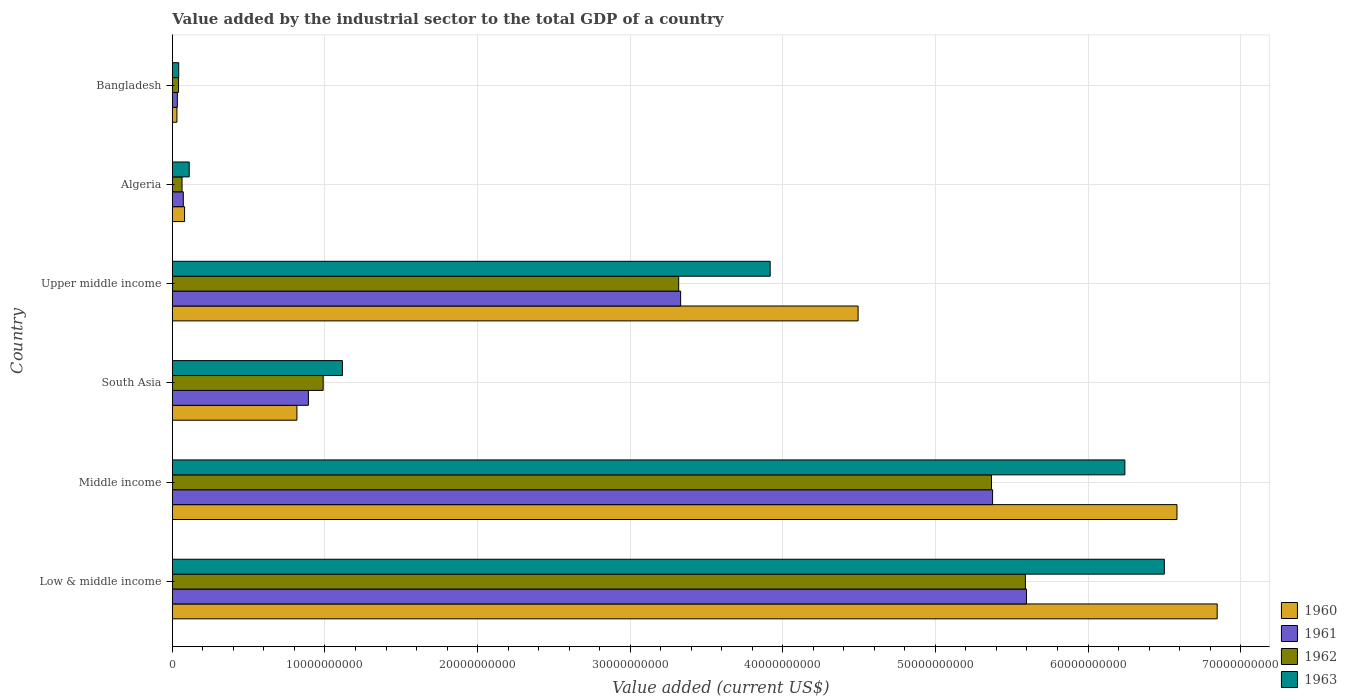How many different coloured bars are there?
Ensure brevity in your answer.  4. How many groups of bars are there?
Offer a very short reply. 6. How many bars are there on the 5th tick from the top?
Offer a very short reply. 4. How many bars are there on the 2nd tick from the bottom?
Make the answer very short. 4. In how many cases, is the number of bars for a given country not equal to the number of legend labels?
Your answer should be very brief. 0. What is the value added by the industrial sector to the total GDP in 1961 in Bangladesh?
Your answer should be very brief. 3.27e+08. Across all countries, what is the maximum value added by the industrial sector to the total GDP in 1962?
Provide a succinct answer. 5.59e+1. Across all countries, what is the minimum value added by the industrial sector to the total GDP in 1962?
Provide a succinct answer. 4.05e+08. In which country was the value added by the industrial sector to the total GDP in 1961 maximum?
Give a very brief answer. Low & middle income. In which country was the value added by the industrial sector to the total GDP in 1961 minimum?
Your answer should be compact. Bangladesh. What is the total value added by the industrial sector to the total GDP in 1961 in the graph?
Offer a terse response. 1.53e+11. What is the difference between the value added by the industrial sector to the total GDP in 1963 in Low & middle income and that in Upper middle income?
Provide a succinct answer. 2.58e+1. What is the difference between the value added by the industrial sector to the total GDP in 1962 in Middle income and the value added by the industrial sector to the total GDP in 1960 in Low & middle income?
Give a very brief answer. -1.48e+1. What is the average value added by the industrial sector to the total GDP in 1961 per country?
Offer a very short reply. 2.55e+1. What is the difference between the value added by the industrial sector to the total GDP in 1961 and value added by the industrial sector to the total GDP in 1962 in Bangladesh?
Your answer should be very brief. -7.74e+07. In how many countries, is the value added by the industrial sector to the total GDP in 1963 greater than 46000000000 US$?
Provide a succinct answer. 2. What is the ratio of the value added by the industrial sector to the total GDP in 1962 in Middle income to that in Upper middle income?
Offer a terse response. 1.62. Is the difference between the value added by the industrial sector to the total GDP in 1961 in South Asia and Upper middle income greater than the difference between the value added by the industrial sector to the total GDP in 1962 in South Asia and Upper middle income?
Provide a short and direct response. No. What is the difference between the highest and the second highest value added by the industrial sector to the total GDP in 1961?
Offer a terse response. 2.22e+09. What is the difference between the highest and the lowest value added by the industrial sector to the total GDP in 1960?
Your answer should be compact. 6.82e+1. In how many countries, is the value added by the industrial sector to the total GDP in 1960 greater than the average value added by the industrial sector to the total GDP in 1960 taken over all countries?
Offer a terse response. 3. What does the 1st bar from the top in Middle income represents?
Your answer should be very brief. 1963. Is it the case that in every country, the sum of the value added by the industrial sector to the total GDP in 1961 and value added by the industrial sector to the total GDP in 1962 is greater than the value added by the industrial sector to the total GDP in 1963?
Offer a terse response. Yes. How many countries are there in the graph?
Offer a very short reply. 6. What is the difference between two consecutive major ticks on the X-axis?
Your answer should be compact. 1.00e+1. Are the values on the major ticks of X-axis written in scientific E-notation?
Ensure brevity in your answer.  No. Does the graph contain grids?
Your answer should be compact. Yes. What is the title of the graph?
Provide a short and direct response. Value added by the industrial sector to the total GDP of a country. Does "1972" appear as one of the legend labels in the graph?
Offer a terse response. No. What is the label or title of the X-axis?
Provide a short and direct response. Value added (current US$). What is the label or title of the Y-axis?
Provide a short and direct response. Country. What is the Value added (current US$) in 1960 in Low & middle income?
Give a very brief answer. 6.85e+1. What is the Value added (current US$) in 1961 in Low & middle income?
Offer a very short reply. 5.60e+1. What is the Value added (current US$) of 1962 in Low & middle income?
Make the answer very short. 5.59e+1. What is the Value added (current US$) of 1963 in Low & middle income?
Provide a succinct answer. 6.50e+1. What is the Value added (current US$) in 1960 in Middle income?
Provide a short and direct response. 6.58e+1. What is the Value added (current US$) in 1961 in Middle income?
Keep it short and to the point. 5.37e+1. What is the Value added (current US$) in 1962 in Middle income?
Give a very brief answer. 5.37e+1. What is the Value added (current US$) in 1963 in Middle income?
Provide a succinct answer. 6.24e+1. What is the Value added (current US$) in 1960 in South Asia?
Give a very brief answer. 8.16e+09. What is the Value added (current US$) in 1961 in South Asia?
Offer a terse response. 8.91e+09. What is the Value added (current US$) in 1962 in South Asia?
Offer a very short reply. 9.88e+09. What is the Value added (current US$) of 1963 in South Asia?
Make the answer very short. 1.11e+1. What is the Value added (current US$) of 1960 in Upper middle income?
Provide a short and direct response. 4.49e+1. What is the Value added (current US$) of 1961 in Upper middle income?
Ensure brevity in your answer.  3.33e+1. What is the Value added (current US$) of 1962 in Upper middle income?
Make the answer very short. 3.32e+1. What is the Value added (current US$) in 1963 in Upper middle income?
Keep it short and to the point. 3.92e+1. What is the Value added (current US$) in 1960 in Algeria?
Offer a very short reply. 8.00e+08. What is the Value added (current US$) in 1961 in Algeria?
Your answer should be very brief. 7.17e+08. What is the Value added (current US$) of 1962 in Algeria?
Your answer should be very brief. 6.34e+08. What is the Value added (current US$) in 1963 in Algeria?
Provide a short and direct response. 1.10e+09. What is the Value added (current US$) in 1960 in Bangladesh?
Give a very brief answer. 2.98e+08. What is the Value added (current US$) of 1961 in Bangladesh?
Your answer should be very brief. 3.27e+08. What is the Value added (current US$) in 1962 in Bangladesh?
Your answer should be very brief. 4.05e+08. What is the Value added (current US$) in 1963 in Bangladesh?
Your answer should be compact. 4.15e+08. Across all countries, what is the maximum Value added (current US$) of 1960?
Give a very brief answer. 6.85e+1. Across all countries, what is the maximum Value added (current US$) of 1961?
Offer a terse response. 5.60e+1. Across all countries, what is the maximum Value added (current US$) of 1962?
Offer a very short reply. 5.59e+1. Across all countries, what is the maximum Value added (current US$) of 1963?
Make the answer very short. 6.50e+1. Across all countries, what is the minimum Value added (current US$) in 1960?
Make the answer very short. 2.98e+08. Across all countries, what is the minimum Value added (current US$) in 1961?
Keep it short and to the point. 3.27e+08. Across all countries, what is the minimum Value added (current US$) of 1962?
Offer a very short reply. 4.05e+08. Across all countries, what is the minimum Value added (current US$) of 1963?
Give a very brief answer. 4.15e+08. What is the total Value added (current US$) of 1960 in the graph?
Keep it short and to the point. 1.88e+11. What is the total Value added (current US$) in 1961 in the graph?
Offer a very short reply. 1.53e+11. What is the total Value added (current US$) in 1962 in the graph?
Your answer should be compact. 1.54e+11. What is the total Value added (current US$) in 1963 in the graph?
Your answer should be very brief. 1.79e+11. What is the difference between the Value added (current US$) in 1960 in Low & middle income and that in Middle income?
Keep it short and to the point. 2.63e+09. What is the difference between the Value added (current US$) of 1961 in Low & middle income and that in Middle income?
Offer a terse response. 2.22e+09. What is the difference between the Value added (current US$) in 1962 in Low & middle income and that in Middle income?
Offer a very short reply. 2.22e+09. What is the difference between the Value added (current US$) in 1963 in Low & middle income and that in Middle income?
Give a very brief answer. 2.59e+09. What is the difference between the Value added (current US$) of 1960 in Low & middle income and that in South Asia?
Make the answer very short. 6.03e+1. What is the difference between the Value added (current US$) of 1961 in Low & middle income and that in South Asia?
Provide a short and direct response. 4.71e+1. What is the difference between the Value added (current US$) of 1962 in Low & middle income and that in South Asia?
Your response must be concise. 4.60e+1. What is the difference between the Value added (current US$) in 1963 in Low & middle income and that in South Asia?
Offer a very short reply. 5.39e+1. What is the difference between the Value added (current US$) in 1960 in Low & middle income and that in Upper middle income?
Ensure brevity in your answer.  2.35e+1. What is the difference between the Value added (current US$) of 1961 in Low & middle income and that in Upper middle income?
Provide a short and direct response. 2.27e+1. What is the difference between the Value added (current US$) in 1962 in Low & middle income and that in Upper middle income?
Your answer should be very brief. 2.27e+1. What is the difference between the Value added (current US$) of 1963 in Low & middle income and that in Upper middle income?
Your response must be concise. 2.58e+1. What is the difference between the Value added (current US$) of 1960 in Low & middle income and that in Algeria?
Your answer should be very brief. 6.77e+1. What is the difference between the Value added (current US$) of 1961 in Low & middle income and that in Algeria?
Ensure brevity in your answer.  5.53e+1. What is the difference between the Value added (current US$) in 1962 in Low & middle income and that in Algeria?
Ensure brevity in your answer.  5.53e+1. What is the difference between the Value added (current US$) in 1963 in Low & middle income and that in Algeria?
Keep it short and to the point. 6.39e+1. What is the difference between the Value added (current US$) in 1960 in Low & middle income and that in Bangladesh?
Offer a terse response. 6.82e+1. What is the difference between the Value added (current US$) in 1961 in Low & middle income and that in Bangladesh?
Offer a terse response. 5.56e+1. What is the difference between the Value added (current US$) in 1962 in Low & middle income and that in Bangladesh?
Your response must be concise. 5.55e+1. What is the difference between the Value added (current US$) in 1963 in Low & middle income and that in Bangladesh?
Your answer should be very brief. 6.46e+1. What is the difference between the Value added (current US$) of 1960 in Middle income and that in South Asia?
Ensure brevity in your answer.  5.77e+1. What is the difference between the Value added (current US$) in 1961 in Middle income and that in South Asia?
Give a very brief answer. 4.48e+1. What is the difference between the Value added (current US$) of 1962 in Middle income and that in South Asia?
Give a very brief answer. 4.38e+1. What is the difference between the Value added (current US$) in 1963 in Middle income and that in South Asia?
Provide a succinct answer. 5.13e+1. What is the difference between the Value added (current US$) of 1960 in Middle income and that in Upper middle income?
Your answer should be compact. 2.09e+1. What is the difference between the Value added (current US$) of 1961 in Middle income and that in Upper middle income?
Your response must be concise. 2.04e+1. What is the difference between the Value added (current US$) in 1962 in Middle income and that in Upper middle income?
Make the answer very short. 2.05e+1. What is the difference between the Value added (current US$) in 1963 in Middle income and that in Upper middle income?
Your answer should be very brief. 2.32e+1. What is the difference between the Value added (current US$) in 1960 in Middle income and that in Algeria?
Keep it short and to the point. 6.50e+1. What is the difference between the Value added (current US$) in 1961 in Middle income and that in Algeria?
Your answer should be very brief. 5.30e+1. What is the difference between the Value added (current US$) in 1962 in Middle income and that in Algeria?
Your response must be concise. 5.30e+1. What is the difference between the Value added (current US$) in 1963 in Middle income and that in Algeria?
Your answer should be compact. 6.13e+1. What is the difference between the Value added (current US$) of 1960 in Middle income and that in Bangladesh?
Ensure brevity in your answer.  6.55e+1. What is the difference between the Value added (current US$) in 1961 in Middle income and that in Bangladesh?
Give a very brief answer. 5.34e+1. What is the difference between the Value added (current US$) in 1962 in Middle income and that in Bangladesh?
Make the answer very short. 5.33e+1. What is the difference between the Value added (current US$) in 1963 in Middle income and that in Bangladesh?
Provide a short and direct response. 6.20e+1. What is the difference between the Value added (current US$) of 1960 in South Asia and that in Upper middle income?
Your answer should be compact. -3.68e+1. What is the difference between the Value added (current US$) of 1961 in South Asia and that in Upper middle income?
Offer a terse response. -2.44e+1. What is the difference between the Value added (current US$) in 1962 in South Asia and that in Upper middle income?
Your answer should be very brief. -2.33e+1. What is the difference between the Value added (current US$) in 1963 in South Asia and that in Upper middle income?
Provide a short and direct response. -2.80e+1. What is the difference between the Value added (current US$) in 1960 in South Asia and that in Algeria?
Offer a terse response. 7.36e+09. What is the difference between the Value added (current US$) in 1961 in South Asia and that in Algeria?
Provide a succinct answer. 8.20e+09. What is the difference between the Value added (current US$) in 1962 in South Asia and that in Algeria?
Provide a short and direct response. 9.25e+09. What is the difference between the Value added (current US$) of 1963 in South Asia and that in Algeria?
Provide a succinct answer. 1.00e+1. What is the difference between the Value added (current US$) of 1960 in South Asia and that in Bangladesh?
Provide a succinct answer. 7.86e+09. What is the difference between the Value added (current US$) in 1961 in South Asia and that in Bangladesh?
Ensure brevity in your answer.  8.59e+09. What is the difference between the Value added (current US$) in 1962 in South Asia and that in Bangladesh?
Offer a terse response. 9.48e+09. What is the difference between the Value added (current US$) in 1963 in South Asia and that in Bangladesh?
Make the answer very short. 1.07e+1. What is the difference between the Value added (current US$) in 1960 in Upper middle income and that in Algeria?
Keep it short and to the point. 4.41e+1. What is the difference between the Value added (current US$) in 1961 in Upper middle income and that in Algeria?
Keep it short and to the point. 3.26e+1. What is the difference between the Value added (current US$) in 1962 in Upper middle income and that in Algeria?
Make the answer very short. 3.25e+1. What is the difference between the Value added (current US$) of 1963 in Upper middle income and that in Algeria?
Your answer should be very brief. 3.81e+1. What is the difference between the Value added (current US$) in 1960 in Upper middle income and that in Bangladesh?
Your response must be concise. 4.46e+1. What is the difference between the Value added (current US$) in 1961 in Upper middle income and that in Bangladesh?
Keep it short and to the point. 3.30e+1. What is the difference between the Value added (current US$) in 1962 in Upper middle income and that in Bangladesh?
Make the answer very short. 3.28e+1. What is the difference between the Value added (current US$) of 1963 in Upper middle income and that in Bangladesh?
Ensure brevity in your answer.  3.88e+1. What is the difference between the Value added (current US$) of 1960 in Algeria and that in Bangladesh?
Your answer should be very brief. 5.02e+08. What is the difference between the Value added (current US$) in 1961 in Algeria and that in Bangladesh?
Provide a short and direct response. 3.90e+08. What is the difference between the Value added (current US$) of 1962 in Algeria and that in Bangladesh?
Make the answer very short. 2.30e+08. What is the difference between the Value added (current US$) in 1963 in Algeria and that in Bangladesh?
Offer a terse response. 6.88e+08. What is the difference between the Value added (current US$) of 1960 in Low & middle income and the Value added (current US$) of 1961 in Middle income?
Offer a terse response. 1.47e+1. What is the difference between the Value added (current US$) of 1960 in Low & middle income and the Value added (current US$) of 1962 in Middle income?
Your response must be concise. 1.48e+1. What is the difference between the Value added (current US$) of 1960 in Low & middle income and the Value added (current US$) of 1963 in Middle income?
Give a very brief answer. 6.05e+09. What is the difference between the Value added (current US$) of 1961 in Low & middle income and the Value added (current US$) of 1962 in Middle income?
Make the answer very short. 2.29e+09. What is the difference between the Value added (current US$) of 1961 in Low & middle income and the Value added (current US$) of 1963 in Middle income?
Your answer should be compact. -6.45e+09. What is the difference between the Value added (current US$) in 1962 in Low & middle income and the Value added (current US$) in 1963 in Middle income?
Your answer should be very brief. -6.52e+09. What is the difference between the Value added (current US$) in 1960 in Low & middle income and the Value added (current US$) in 1961 in South Asia?
Your answer should be compact. 5.96e+1. What is the difference between the Value added (current US$) in 1960 in Low & middle income and the Value added (current US$) in 1962 in South Asia?
Your answer should be compact. 5.86e+1. What is the difference between the Value added (current US$) in 1960 in Low & middle income and the Value added (current US$) in 1963 in South Asia?
Make the answer very short. 5.73e+1. What is the difference between the Value added (current US$) of 1961 in Low & middle income and the Value added (current US$) of 1962 in South Asia?
Your answer should be compact. 4.61e+1. What is the difference between the Value added (current US$) of 1961 in Low & middle income and the Value added (current US$) of 1963 in South Asia?
Provide a short and direct response. 4.48e+1. What is the difference between the Value added (current US$) in 1962 in Low & middle income and the Value added (current US$) in 1963 in South Asia?
Your answer should be compact. 4.48e+1. What is the difference between the Value added (current US$) in 1960 in Low & middle income and the Value added (current US$) in 1961 in Upper middle income?
Your response must be concise. 3.52e+1. What is the difference between the Value added (current US$) in 1960 in Low & middle income and the Value added (current US$) in 1962 in Upper middle income?
Make the answer very short. 3.53e+1. What is the difference between the Value added (current US$) in 1960 in Low & middle income and the Value added (current US$) in 1963 in Upper middle income?
Your answer should be compact. 2.93e+1. What is the difference between the Value added (current US$) of 1961 in Low & middle income and the Value added (current US$) of 1962 in Upper middle income?
Your answer should be compact. 2.28e+1. What is the difference between the Value added (current US$) of 1961 in Low & middle income and the Value added (current US$) of 1963 in Upper middle income?
Your response must be concise. 1.68e+1. What is the difference between the Value added (current US$) of 1962 in Low & middle income and the Value added (current US$) of 1963 in Upper middle income?
Give a very brief answer. 1.67e+1. What is the difference between the Value added (current US$) of 1960 in Low & middle income and the Value added (current US$) of 1961 in Algeria?
Keep it short and to the point. 6.77e+1. What is the difference between the Value added (current US$) of 1960 in Low & middle income and the Value added (current US$) of 1962 in Algeria?
Your answer should be compact. 6.78e+1. What is the difference between the Value added (current US$) of 1960 in Low & middle income and the Value added (current US$) of 1963 in Algeria?
Your response must be concise. 6.74e+1. What is the difference between the Value added (current US$) of 1961 in Low & middle income and the Value added (current US$) of 1962 in Algeria?
Provide a succinct answer. 5.53e+1. What is the difference between the Value added (current US$) of 1961 in Low & middle income and the Value added (current US$) of 1963 in Algeria?
Provide a short and direct response. 5.49e+1. What is the difference between the Value added (current US$) in 1962 in Low & middle income and the Value added (current US$) in 1963 in Algeria?
Provide a succinct answer. 5.48e+1. What is the difference between the Value added (current US$) in 1960 in Low & middle income and the Value added (current US$) in 1961 in Bangladesh?
Give a very brief answer. 6.81e+1. What is the difference between the Value added (current US$) in 1960 in Low & middle income and the Value added (current US$) in 1962 in Bangladesh?
Your response must be concise. 6.81e+1. What is the difference between the Value added (current US$) of 1960 in Low & middle income and the Value added (current US$) of 1963 in Bangladesh?
Your answer should be very brief. 6.81e+1. What is the difference between the Value added (current US$) in 1961 in Low & middle income and the Value added (current US$) in 1962 in Bangladesh?
Provide a succinct answer. 5.56e+1. What is the difference between the Value added (current US$) of 1961 in Low & middle income and the Value added (current US$) of 1963 in Bangladesh?
Your answer should be very brief. 5.56e+1. What is the difference between the Value added (current US$) in 1962 in Low & middle income and the Value added (current US$) in 1963 in Bangladesh?
Offer a terse response. 5.55e+1. What is the difference between the Value added (current US$) of 1960 in Middle income and the Value added (current US$) of 1961 in South Asia?
Provide a succinct answer. 5.69e+1. What is the difference between the Value added (current US$) in 1960 in Middle income and the Value added (current US$) in 1962 in South Asia?
Keep it short and to the point. 5.59e+1. What is the difference between the Value added (current US$) of 1960 in Middle income and the Value added (current US$) of 1963 in South Asia?
Offer a terse response. 5.47e+1. What is the difference between the Value added (current US$) in 1961 in Middle income and the Value added (current US$) in 1962 in South Asia?
Your answer should be compact. 4.39e+1. What is the difference between the Value added (current US$) in 1961 in Middle income and the Value added (current US$) in 1963 in South Asia?
Your answer should be very brief. 4.26e+1. What is the difference between the Value added (current US$) of 1962 in Middle income and the Value added (current US$) of 1963 in South Asia?
Your answer should be very brief. 4.25e+1. What is the difference between the Value added (current US$) of 1960 in Middle income and the Value added (current US$) of 1961 in Upper middle income?
Your response must be concise. 3.25e+1. What is the difference between the Value added (current US$) in 1960 in Middle income and the Value added (current US$) in 1962 in Upper middle income?
Your answer should be compact. 3.27e+1. What is the difference between the Value added (current US$) of 1960 in Middle income and the Value added (current US$) of 1963 in Upper middle income?
Make the answer very short. 2.67e+1. What is the difference between the Value added (current US$) in 1961 in Middle income and the Value added (current US$) in 1962 in Upper middle income?
Make the answer very short. 2.06e+1. What is the difference between the Value added (current US$) in 1961 in Middle income and the Value added (current US$) in 1963 in Upper middle income?
Ensure brevity in your answer.  1.46e+1. What is the difference between the Value added (current US$) in 1962 in Middle income and the Value added (current US$) in 1963 in Upper middle income?
Offer a terse response. 1.45e+1. What is the difference between the Value added (current US$) of 1960 in Middle income and the Value added (current US$) of 1961 in Algeria?
Your answer should be very brief. 6.51e+1. What is the difference between the Value added (current US$) of 1960 in Middle income and the Value added (current US$) of 1962 in Algeria?
Your answer should be compact. 6.52e+1. What is the difference between the Value added (current US$) in 1960 in Middle income and the Value added (current US$) in 1963 in Algeria?
Give a very brief answer. 6.47e+1. What is the difference between the Value added (current US$) in 1961 in Middle income and the Value added (current US$) in 1962 in Algeria?
Offer a very short reply. 5.31e+1. What is the difference between the Value added (current US$) in 1961 in Middle income and the Value added (current US$) in 1963 in Algeria?
Offer a very short reply. 5.26e+1. What is the difference between the Value added (current US$) in 1962 in Middle income and the Value added (current US$) in 1963 in Algeria?
Keep it short and to the point. 5.26e+1. What is the difference between the Value added (current US$) of 1960 in Middle income and the Value added (current US$) of 1961 in Bangladesh?
Provide a succinct answer. 6.55e+1. What is the difference between the Value added (current US$) of 1960 in Middle income and the Value added (current US$) of 1962 in Bangladesh?
Offer a very short reply. 6.54e+1. What is the difference between the Value added (current US$) in 1960 in Middle income and the Value added (current US$) in 1963 in Bangladesh?
Offer a very short reply. 6.54e+1. What is the difference between the Value added (current US$) of 1961 in Middle income and the Value added (current US$) of 1962 in Bangladesh?
Offer a terse response. 5.33e+1. What is the difference between the Value added (current US$) of 1961 in Middle income and the Value added (current US$) of 1963 in Bangladesh?
Your answer should be compact. 5.33e+1. What is the difference between the Value added (current US$) in 1962 in Middle income and the Value added (current US$) in 1963 in Bangladesh?
Make the answer very short. 5.33e+1. What is the difference between the Value added (current US$) of 1960 in South Asia and the Value added (current US$) of 1961 in Upper middle income?
Provide a succinct answer. -2.51e+1. What is the difference between the Value added (current US$) in 1960 in South Asia and the Value added (current US$) in 1962 in Upper middle income?
Keep it short and to the point. -2.50e+1. What is the difference between the Value added (current US$) of 1960 in South Asia and the Value added (current US$) of 1963 in Upper middle income?
Keep it short and to the point. -3.10e+1. What is the difference between the Value added (current US$) of 1961 in South Asia and the Value added (current US$) of 1962 in Upper middle income?
Provide a short and direct response. -2.43e+1. What is the difference between the Value added (current US$) of 1961 in South Asia and the Value added (current US$) of 1963 in Upper middle income?
Provide a short and direct response. -3.03e+1. What is the difference between the Value added (current US$) in 1962 in South Asia and the Value added (current US$) in 1963 in Upper middle income?
Ensure brevity in your answer.  -2.93e+1. What is the difference between the Value added (current US$) in 1960 in South Asia and the Value added (current US$) in 1961 in Algeria?
Your answer should be compact. 7.44e+09. What is the difference between the Value added (current US$) in 1960 in South Asia and the Value added (current US$) in 1962 in Algeria?
Make the answer very short. 7.53e+09. What is the difference between the Value added (current US$) in 1960 in South Asia and the Value added (current US$) in 1963 in Algeria?
Give a very brief answer. 7.06e+09. What is the difference between the Value added (current US$) in 1961 in South Asia and the Value added (current US$) in 1962 in Algeria?
Make the answer very short. 8.28e+09. What is the difference between the Value added (current US$) of 1961 in South Asia and the Value added (current US$) of 1963 in Algeria?
Keep it short and to the point. 7.81e+09. What is the difference between the Value added (current US$) in 1962 in South Asia and the Value added (current US$) in 1963 in Algeria?
Your answer should be very brief. 8.78e+09. What is the difference between the Value added (current US$) in 1960 in South Asia and the Value added (current US$) in 1961 in Bangladesh?
Offer a terse response. 7.83e+09. What is the difference between the Value added (current US$) of 1960 in South Asia and the Value added (current US$) of 1962 in Bangladesh?
Provide a short and direct response. 7.76e+09. What is the difference between the Value added (current US$) of 1960 in South Asia and the Value added (current US$) of 1963 in Bangladesh?
Make the answer very short. 7.75e+09. What is the difference between the Value added (current US$) in 1961 in South Asia and the Value added (current US$) in 1962 in Bangladesh?
Keep it short and to the point. 8.51e+09. What is the difference between the Value added (current US$) of 1961 in South Asia and the Value added (current US$) of 1963 in Bangladesh?
Make the answer very short. 8.50e+09. What is the difference between the Value added (current US$) in 1962 in South Asia and the Value added (current US$) in 1963 in Bangladesh?
Provide a short and direct response. 9.47e+09. What is the difference between the Value added (current US$) in 1960 in Upper middle income and the Value added (current US$) in 1961 in Algeria?
Make the answer very short. 4.42e+1. What is the difference between the Value added (current US$) in 1960 in Upper middle income and the Value added (current US$) in 1962 in Algeria?
Keep it short and to the point. 4.43e+1. What is the difference between the Value added (current US$) of 1960 in Upper middle income and the Value added (current US$) of 1963 in Algeria?
Your answer should be compact. 4.38e+1. What is the difference between the Value added (current US$) in 1961 in Upper middle income and the Value added (current US$) in 1962 in Algeria?
Provide a short and direct response. 3.27e+1. What is the difference between the Value added (current US$) in 1961 in Upper middle income and the Value added (current US$) in 1963 in Algeria?
Give a very brief answer. 3.22e+1. What is the difference between the Value added (current US$) of 1962 in Upper middle income and the Value added (current US$) of 1963 in Algeria?
Offer a terse response. 3.21e+1. What is the difference between the Value added (current US$) of 1960 in Upper middle income and the Value added (current US$) of 1961 in Bangladesh?
Your response must be concise. 4.46e+1. What is the difference between the Value added (current US$) in 1960 in Upper middle income and the Value added (current US$) in 1962 in Bangladesh?
Ensure brevity in your answer.  4.45e+1. What is the difference between the Value added (current US$) of 1960 in Upper middle income and the Value added (current US$) of 1963 in Bangladesh?
Make the answer very short. 4.45e+1. What is the difference between the Value added (current US$) in 1961 in Upper middle income and the Value added (current US$) in 1962 in Bangladesh?
Offer a terse response. 3.29e+1. What is the difference between the Value added (current US$) in 1961 in Upper middle income and the Value added (current US$) in 1963 in Bangladesh?
Keep it short and to the point. 3.29e+1. What is the difference between the Value added (current US$) of 1962 in Upper middle income and the Value added (current US$) of 1963 in Bangladesh?
Provide a short and direct response. 3.28e+1. What is the difference between the Value added (current US$) in 1960 in Algeria and the Value added (current US$) in 1961 in Bangladesh?
Your answer should be compact. 4.73e+08. What is the difference between the Value added (current US$) in 1960 in Algeria and the Value added (current US$) in 1962 in Bangladesh?
Make the answer very short. 3.95e+08. What is the difference between the Value added (current US$) in 1960 in Algeria and the Value added (current US$) in 1963 in Bangladesh?
Provide a succinct answer. 3.85e+08. What is the difference between the Value added (current US$) in 1961 in Algeria and the Value added (current US$) in 1962 in Bangladesh?
Give a very brief answer. 3.12e+08. What is the difference between the Value added (current US$) of 1961 in Algeria and the Value added (current US$) of 1963 in Bangladesh?
Your response must be concise. 3.02e+08. What is the difference between the Value added (current US$) of 1962 in Algeria and the Value added (current US$) of 1963 in Bangladesh?
Provide a succinct answer. 2.19e+08. What is the average Value added (current US$) in 1960 per country?
Offer a very short reply. 3.14e+1. What is the average Value added (current US$) of 1961 per country?
Your response must be concise. 2.55e+1. What is the average Value added (current US$) in 1962 per country?
Offer a terse response. 2.56e+1. What is the average Value added (current US$) of 1963 per country?
Keep it short and to the point. 2.99e+1. What is the difference between the Value added (current US$) in 1960 and Value added (current US$) in 1961 in Low & middle income?
Your answer should be compact. 1.25e+1. What is the difference between the Value added (current US$) of 1960 and Value added (current US$) of 1962 in Low & middle income?
Keep it short and to the point. 1.26e+1. What is the difference between the Value added (current US$) of 1960 and Value added (current US$) of 1963 in Low & middle income?
Your answer should be very brief. 3.46e+09. What is the difference between the Value added (current US$) of 1961 and Value added (current US$) of 1962 in Low & middle income?
Offer a very short reply. 7.11e+07. What is the difference between the Value added (current US$) of 1961 and Value added (current US$) of 1963 in Low & middle income?
Your response must be concise. -9.03e+09. What is the difference between the Value added (current US$) of 1962 and Value added (current US$) of 1963 in Low & middle income?
Make the answer very short. -9.10e+09. What is the difference between the Value added (current US$) in 1960 and Value added (current US$) in 1961 in Middle income?
Your answer should be compact. 1.21e+1. What is the difference between the Value added (current US$) in 1960 and Value added (current US$) in 1962 in Middle income?
Your answer should be very brief. 1.22e+1. What is the difference between the Value added (current US$) of 1960 and Value added (current US$) of 1963 in Middle income?
Your answer should be very brief. 3.41e+09. What is the difference between the Value added (current US$) of 1961 and Value added (current US$) of 1962 in Middle income?
Ensure brevity in your answer.  7.12e+07. What is the difference between the Value added (current US$) of 1961 and Value added (current US$) of 1963 in Middle income?
Your response must be concise. -8.67e+09. What is the difference between the Value added (current US$) of 1962 and Value added (current US$) of 1963 in Middle income?
Give a very brief answer. -8.74e+09. What is the difference between the Value added (current US$) of 1960 and Value added (current US$) of 1961 in South Asia?
Offer a very short reply. -7.53e+08. What is the difference between the Value added (current US$) in 1960 and Value added (current US$) in 1962 in South Asia?
Offer a terse response. -1.72e+09. What is the difference between the Value added (current US$) of 1960 and Value added (current US$) of 1963 in South Asia?
Offer a very short reply. -2.98e+09. What is the difference between the Value added (current US$) of 1961 and Value added (current US$) of 1962 in South Asia?
Offer a terse response. -9.68e+08. What is the difference between the Value added (current US$) in 1961 and Value added (current US$) in 1963 in South Asia?
Offer a terse response. -2.23e+09. What is the difference between the Value added (current US$) of 1962 and Value added (current US$) of 1963 in South Asia?
Make the answer very short. -1.26e+09. What is the difference between the Value added (current US$) in 1960 and Value added (current US$) in 1961 in Upper middle income?
Your answer should be compact. 1.16e+1. What is the difference between the Value added (current US$) of 1960 and Value added (current US$) of 1962 in Upper middle income?
Your response must be concise. 1.18e+1. What is the difference between the Value added (current US$) of 1960 and Value added (current US$) of 1963 in Upper middle income?
Your response must be concise. 5.76e+09. What is the difference between the Value added (current US$) in 1961 and Value added (current US$) in 1962 in Upper middle income?
Offer a very short reply. 1.26e+08. What is the difference between the Value added (current US$) in 1961 and Value added (current US$) in 1963 in Upper middle income?
Provide a succinct answer. -5.87e+09. What is the difference between the Value added (current US$) in 1962 and Value added (current US$) in 1963 in Upper middle income?
Provide a short and direct response. -5.99e+09. What is the difference between the Value added (current US$) of 1960 and Value added (current US$) of 1961 in Algeria?
Ensure brevity in your answer.  8.27e+07. What is the difference between the Value added (current US$) of 1960 and Value added (current US$) of 1962 in Algeria?
Provide a succinct answer. 1.65e+08. What is the difference between the Value added (current US$) of 1960 and Value added (current US$) of 1963 in Algeria?
Offer a terse response. -3.03e+08. What is the difference between the Value added (current US$) of 1961 and Value added (current US$) of 1962 in Algeria?
Your answer should be very brief. 8.27e+07. What is the difference between the Value added (current US$) of 1961 and Value added (current US$) of 1963 in Algeria?
Provide a short and direct response. -3.86e+08. What is the difference between the Value added (current US$) of 1962 and Value added (current US$) of 1963 in Algeria?
Make the answer very short. -4.69e+08. What is the difference between the Value added (current US$) in 1960 and Value added (current US$) in 1961 in Bangladesh?
Make the answer very short. -2.92e+07. What is the difference between the Value added (current US$) in 1960 and Value added (current US$) in 1962 in Bangladesh?
Offer a terse response. -1.07e+08. What is the difference between the Value added (current US$) of 1960 and Value added (current US$) of 1963 in Bangladesh?
Give a very brief answer. -1.17e+08. What is the difference between the Value added (current US$) in 1961 and Value added (current US$) in 1962 in Bangladesh?
Your response must be concise. -7.74e+07. What is the difference between the Value added (current US$) of 1961 and Value added (current US$) of 1963 in Bangladesh?
Provide a succinct answer. -8.78e+07. What is the difference between the Value added (current US$) in 1962 and Value added (current US$) in 1963 in Bangladesh?
Your answer should be very brief. -1.05e+07. What is the ratio of the Value added (current US$) in 1961 in Low & middle income to that in Middle income?
Keep it short and to the point. 1.04. What is the ratio of the Value added (current US$) in 1962 in Low & middle income to that in Middle income?
Provide a short and direct response. 1.04. What is the ratio of the Value added (current US$) in 1963 in Low & middle income to that in Middle income?
Your answer should be compact. 1.04. What is the ratio of the Value added (current US$) in 1960 in Low & middle income to that in South Asia?
Offer a terse response. 8.39. What is the ratio of the Value added (current US$) of 1961 in Low & middle income to that in South Asia?
Give a very brief answer. 6.28. What is the ratio of the Value added (current US$) of 1962 in Low & middle income to that in South Asia?
Ensure brevity in your answer.  5.66. What is the ratio of the Value added (current US$) in 1963 in Low & middle income to that in South Asia?
Ensure brevity in your answer.  5.83. What is the ratio of the Value added (current US$) of 1960 in Low & middle income to that in Upper middle income?
Ensure brevity in your answer.  1.52. What is the ratio of the Value added (current US$) in 1961 in Low & middle income to that in Upper middle income?
Offer a terse response. 1.68. What is the ratio of the Value added (current US$) in 1962 in Low & middle income to that in Upper middle income?
Your response must be concise. 1.68. What is the ratio of the Value added (current US$) of 1963 in Low & middle income to that in Upper middle income?
Keep it short and to the point. 1.66. What is the ratio of the Value added (current US$) in 1960 in Low & middle income to that in Algeria?
Your answer should be very brief. 85.59. What is the ratio of the Value added (current US$) of 1961 in Low & middle income to that in Algeria?
Ensure brevity in your answer.  78.04. What is the ratio of the Value added (current US$) of 1962 in Low & middle income to that in Algeria?
Your response must be concise. 88.11. What is the ratio of the Value added (current US$) of 1963 in Low & middle income to that in Algeria?
Ensure brevity in your answer.  58.91. What is the ratio of the Value added (current US$) in 1960 in Low & middle income to that in Bangladesh?
Your answer should be very brief. 229.65. What is the ratio of the Value added (current US$) of 1961 in Low & middle income to that in Bangladesh?
Give a very brief answer. 171. What is the ratio of the Value added (current US$) of 1962 in Low & middle income to that in Bangladesh?
Make the answer very short. 138.13. What is the ratio of the Value added (current US$) of 1963 in Low & middle income to that in Bangladesh?
Offer a terse response. 156.57. What is the ratio of the Value added (current US$) of 1960 in Middle income to that in South Asia?
Offer a very short reply. 8.07. What is the ratio of the Value added (current US$) in 1961 in Middle income to that in South Asia?
Keep it short and to the point. 6.03. What is the ratio of the Value added (current US$) of 1962 in Middle income to that in South Asia?
Offer a very short reply. 5.43. What is the ratio of the Value added (current US$) in 1963 in Middle income to that in South Asia?
Offer a terse response. 5.6. What is the ratio of the Value added (current US$) in 1960 in Middle income to that in Upper middle income?
Your answer should be compact. 1.47. What is the ratio of the Value added (current US$) in 1961 in Middle income to that in Upper middle income?
Offer a terse response. 1.61. What is the ratio of the Value added (current US$) of 1962 in Middle income to that in Upper middle income?
Your answer should be compact. 1.62. What is the ratio of the Value added (current US$) of 1963 in Middle income to that in Upper middle income?
Provide a succinct answer. 1.59. What is the ratio of the Value added (current US$) of 1960 in Middle income to that in Algeria?
Your answer should be compact. 82.3. What is the ratio of the Value added (current US$) of 1961 in Middle income to that in Algeria?
Provide a short and direct response. 74.95. What is the ratio of the Value added (current US$) in 1962 in Middle income to that in Algeria?
Your answer should be very brief. 84.61. What is the ratio of the Value added (current US$) in 1963 in Middle income to that in Algeria?
Your response must be concise. 56.57. What is the ratio of the Value added (current US$) of 1960 in Middle income to that in Bangladesh?
Offer a very short reply. 220.82. What is the ratio of the Value added (current US$) of 1961 in Middle income to that in Bangladesh?
Your answer should be very brief. 164.21. What is the ratio of the Value added (current US$) of 1962 in Middle income to that in Bangladesh?
Give a very brief answer. 132.64. What is the ratio of the Value added (current US$) of 1963 in Middle income to that in Bangladesh?
Your response must be concise. 150.34. What is the ratio of the Value added (current US$) of 1960 in South Asia to that in Upper middle income?
Give a very brief answer. 0.18. What is the ratio of the Value added (current US$) of 1961 in South Asia to that in Upper middle income?
Make the answer very short. 0.27. What is the ratio of the Value added (current US$) of 1962 in South Asia to that in Upper middle income?
Give a very brief answer. 0.3. What is the ratio of the Value added (current US$) of 1963 in South Asia to that in Upper middle income?
Your response must be concise. 0.28. What is the ratio of the Value added (current US$) of 1960 in South Asia to that in Algeria?
Provide a succinct answer. 10.2. What is the ratio of the Value added (current US$) of 1961 in South Asia to that in Algeria?
Your answer should be very brief. 12.43. What is the ratio of the Value added (current US$) of 1962 in South Asia to that in Algeria?
Provide a short and direct response. 15.58. What is the ratio of the Value added (current US$) of 1963 in South Asia to that in Algeria?
Keep it short and to the point. 10.1. What is the ratio of the Value added (current US$) in 1960 in South Asia to that in Bangladesh?
Provide a succinct answer. 27.38. What is the ratio of the Value added (current US$) of 1961 in South Asia to that in Bangladesh?
Offer a very short reply. 27.24. What is the ratio of the Value added (current US$) in 1962 in South Asia to that in Bangladesh?
Offer a very short reply. 24.42. What is the ratio of the Value added (current US$) in 1963 in South Asia to that in Bangladesh?
Ensure brevity in your answer.  26.84. What is the ratio of the Value added (current US$) in 1960 in Upper middle income to that in Algeria?
Offer a very short reply. 56.17. What is the ratio of the Value added (current US$) of 1961 in Upper middle income to that in Algeria?
Offer a very short reply. 46.44. What is the ratio of the Value added (current US$) of 1962 in Upper middle income to that in Algeria?
Your response must be concise. 52.3. What is the ratio of the Value added (current US$) of 1963 in Upper middle income to that in Algeria?
Your answer should be compact. 35.5. What is the ratio of the Value added (current US$) in 1960 in Upper middle income to that in Bangladesh?
Provide a short and direct response. 150.72. What is the ratio of the Value added (current US$) in 1961 in Upper middle income to that in Bangladesh?
Keep it short and to the point. 101.75. What is the ratio of the Value added (current US$) in 1962 in Upper middle income to that in Bangladesh?
Give a very brief answer. 81.99. What is the ratio of the Value added (current US$) of 1963 in Upper middle income to that in Bangladesh?
Give a very brief answer. 94.36. What is the ratio of the Value added (current US$) in 1960 in Algeria to that in Bangladesh?
Offer a terse response. 2.68. What is the ratio of the Value added (current US$) in 1961 in Algeria to that in Bangladesh?
Keep it short and to the point. 2.19. What is the ratio of the Value added (current US$) of 1962 in Algeria to that in Bangladesh?
Your response must be concise. 1.57. What is the ratio of the Value added (current US$) of 1963 in Algeria to that in Bangladesh?
Provide a succinct answer. 2.66. What is the difference between the highest and the second highest Value added (current US$) in 1960?
Make the answer very short. 2.63e+09. What is the difference between the highest and the second highest Value added (current US$) of 1961?
Provide a succinct answer. 2.22e+09. What is the difference between the highest and the second highest Value added (current US$) in 1962?
Make the answer very short. 2.22e+09. What is the difference between the highest and the second highest Value added (current US$) of 1963?
Offer a terse response. 2.59e+09. What is the difference between the highest and the lowest Value added (current US$) in 1960?
Provide a short and direct response. 6.82e+1. What is the difference between the highest and the lowest Value added (current US$) of 1961?
Provide a short and direct response. 5.56e+1. What is the difference between the highest and the lowest Value added (current US$) in 1962?
Keep it short and to the point. 5.55e+1. What is the difference between the highest and the lowest Value added (current US$) in 1963?
Offer a very short reply. 6.46e+1. 